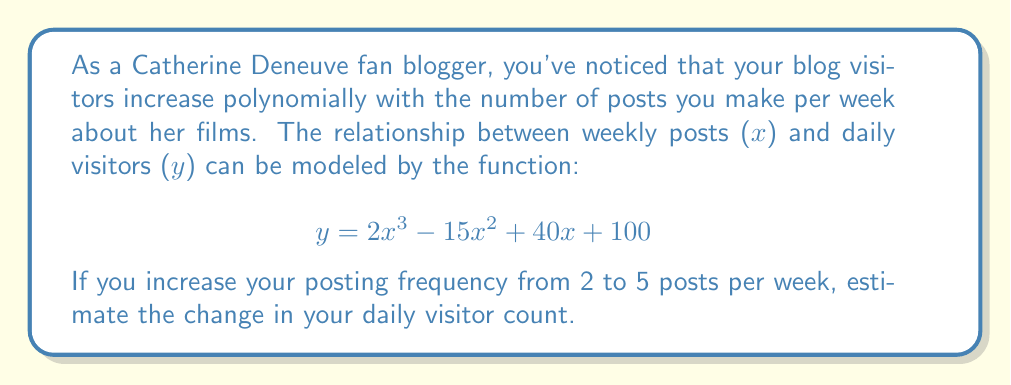Show me your answer to this math problem. To solve this problem, we need to follow these steps:

1. Calculate the number of daily visitors for 2 posts per week:
   $$ y(2) = 2(2)^3 - 15(2)^2 + 40(2) + 100 $$
   $$ y(2) = 2(8) - 15(4) + 80 + 100 $$
   $$ y(2) = 16 - 60 + 80 + 100 = 136 $$ visitors

2. Calculate the number of daily visitors for 5 posts per week:
   $$ y(5) = 2(5)^3 - 15(5)^2 + 40(5) + 100 $$
   $$ y(5) = 2(125) - 15(25) + 200 + 100 $$
   $$ y(5) = 250 - 375 + 200 + 100 = 175 $$ visitors

3. Calculate the difference between the two results:
   $$ \text{Change in visitors} = y(5) - y(2) = 175 - 136 = 39 $$

Therefore, by increasing your posting frequency from 2 to 5 posts per week about Catherine Deneuve's films, you can expect an increase of 39 daily visitors to your blog.
Answer: The estimated change in daily visitor count is an increase of 39 visitors. 